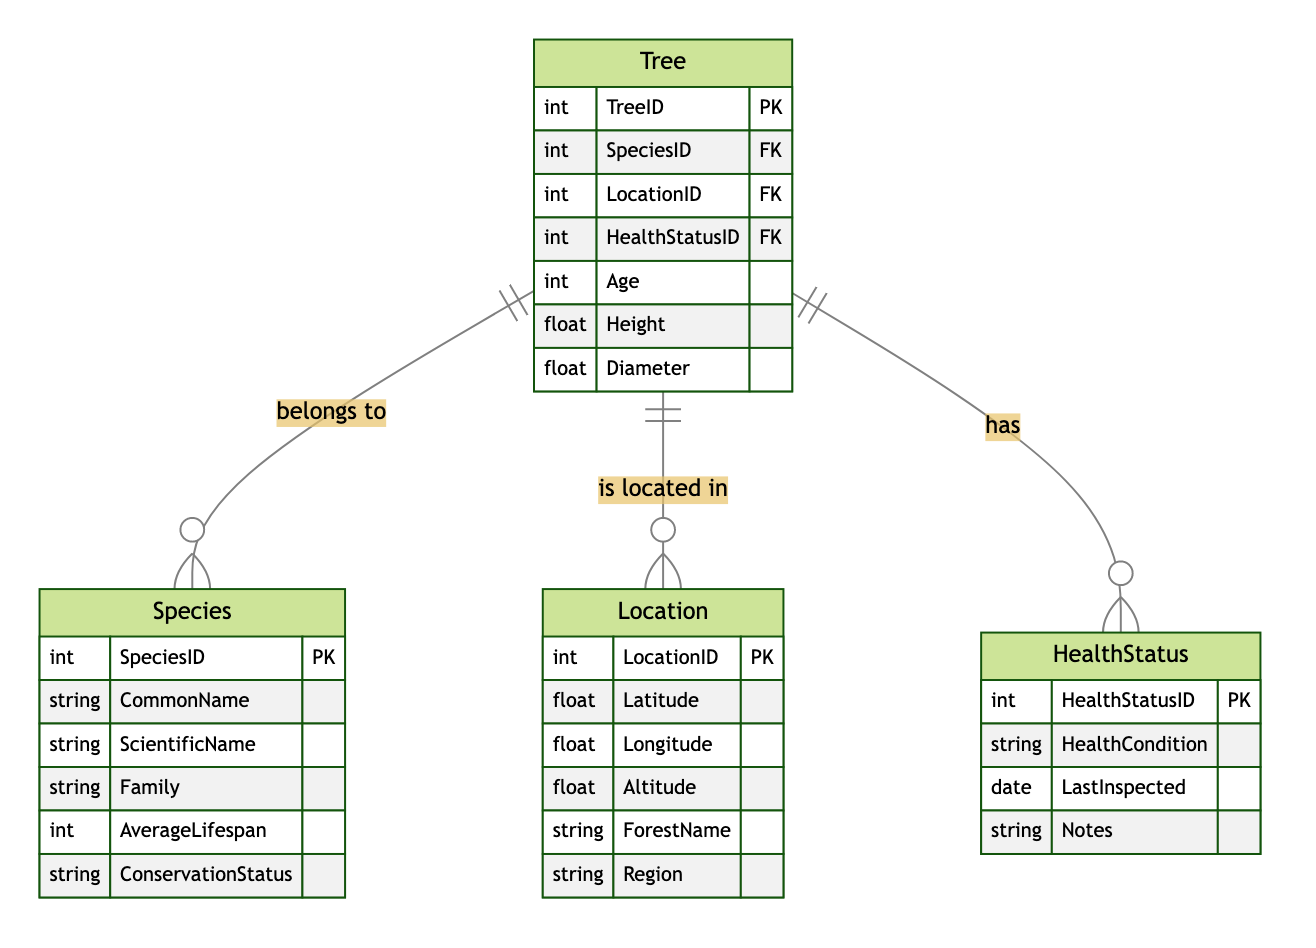What are the entities in this diagram? The diagram features four main entities: Tree, Species, Location, and HealthStatus. Each entity has specific attributes associated with it that define its characteristics.
Answer: Tree, Species, Location, HealthStatus How many attributes does the Tree entity have? The Tree entity contains seven attributes, which include TreeID, SpeciesID, LocationID, HealthStatusID, Age, Height, and Diameter.
Answer: Seven What type of relationship exists between Tree and Species? The relationship between Tree and Species is a Many-to-One relationship, meaning that many trees can belong to one species. This is indicated by the connecting line with notation.
Answer: Many-to-One What attribute connects the Tree to its Location? The LocationID attribute in the Tree entity connects it to its associated Location, indicating where the tree is located geographically.
Answer: LocationID What is the average lifespan of a species? The average lifespan is an attribute found within the Species entity, indicating how long a particular species is expected to live under normal conditions.
Answer: AverageLifespan How are HealthStatus and Tree related? The relationship between HealthStatus and Tree is Many-to-One, meaning each tree can have one health status, but the same health status can apply to multiple trees.
Answer: Many-to-One What is indicated by the LastInspected attribute in the HealthStatus entity? The LastInspected attribute records the most recent date on which the health of the tree was inspected, providing insight into the health monitoring process.
Answer: LastInspected Which entity contains geographical attributes? The Location entity contains geographical attributes including Latitude, Longitude, and Altitude, which are essential for identifying the exact location of trees within the forest.
Answer: Location What does the HealthCondition attribute describe? The HealthCondition attribute describes the current health status of the tree, detailing whether it is healthy, diseased, or in some form of distress.
Answer: HealthCondition 